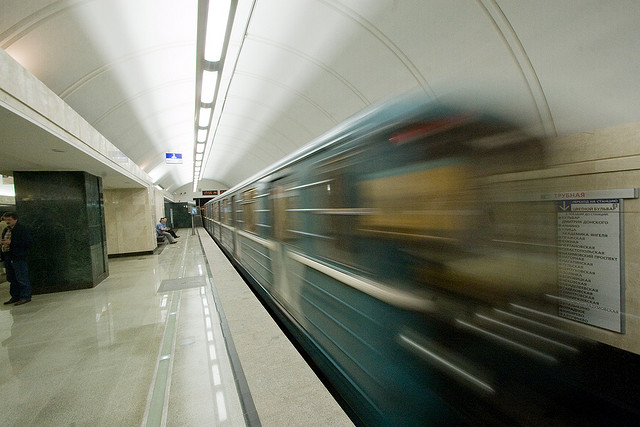Is the overall lighting in the image sufficient? The lighting in the image appears to be adequate for capturing the essence of a bustling subway station. It highlights the motion blur of the train, suggesting speed, while allowing details of the stationary platform and the standing individual to remain visible and sharp. The ambient lighting accentuates the curvature of the architecture and provides a clear view of informative signage along the platform wall. 